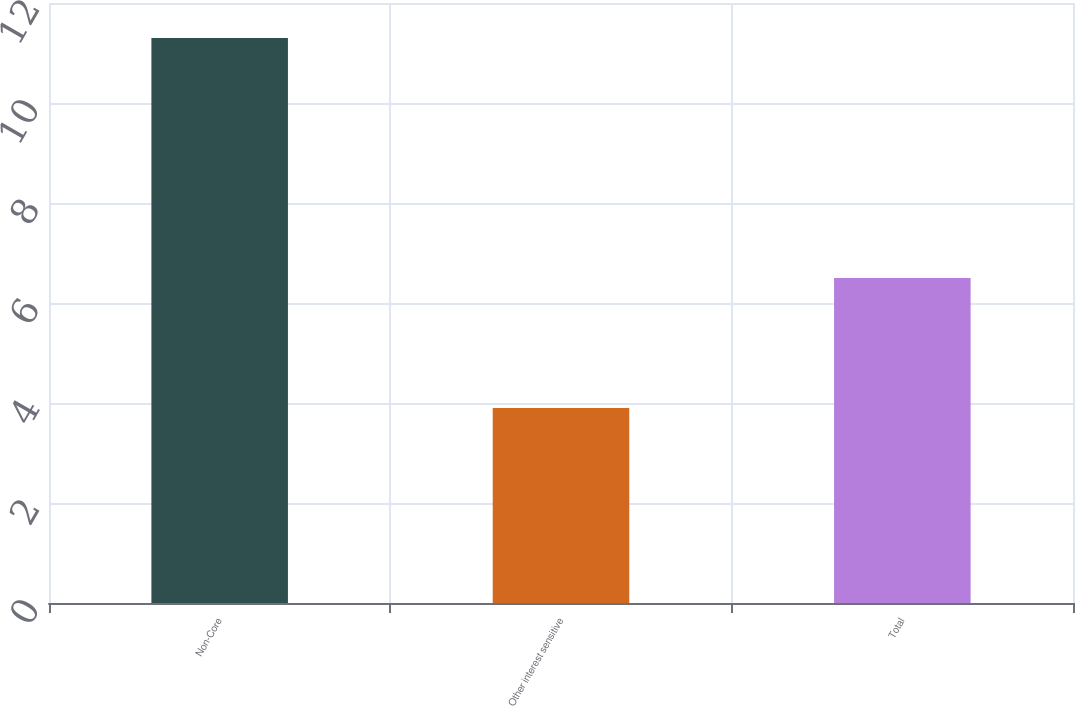Convert chart. <chart><loc_0><loc_0><loc_500><loc_500><bar_chart><fcel>Non-Core<fcel>Other interest sensitive<fcel>Total<nl><fcel>11.3<fcel>3.9<fcel>6.5<nl></chart> 